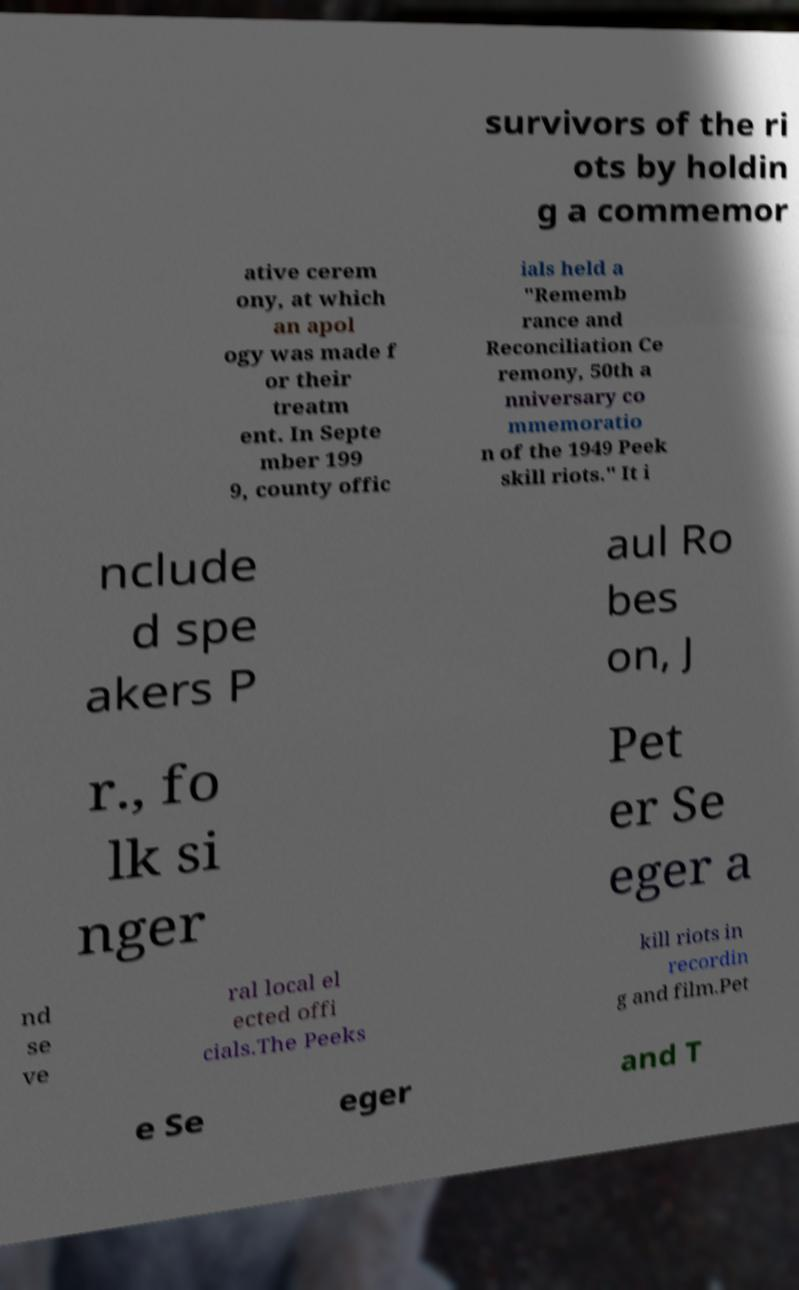What messages or text are displayed in this image? I need them in a readable, typed format. survivors of the ri ots by holdin g a commemor ative cerem ony, at which an apol ogy was made f or their treatm ent. In Septe mber 199 9, county offic ials held a "Rememb rance and Reconciliation Ce remony, 50th a nniversary co mmemoratio n of the 1949 Peek skill riots." It i nclude d spe akers P aul Ro bes on, J r., fo lk si nger Pet er Se eger a nd se ve ral local el ected offi cials.The Peeks kill riots in recordin g and film.Pet e Se eger and T 